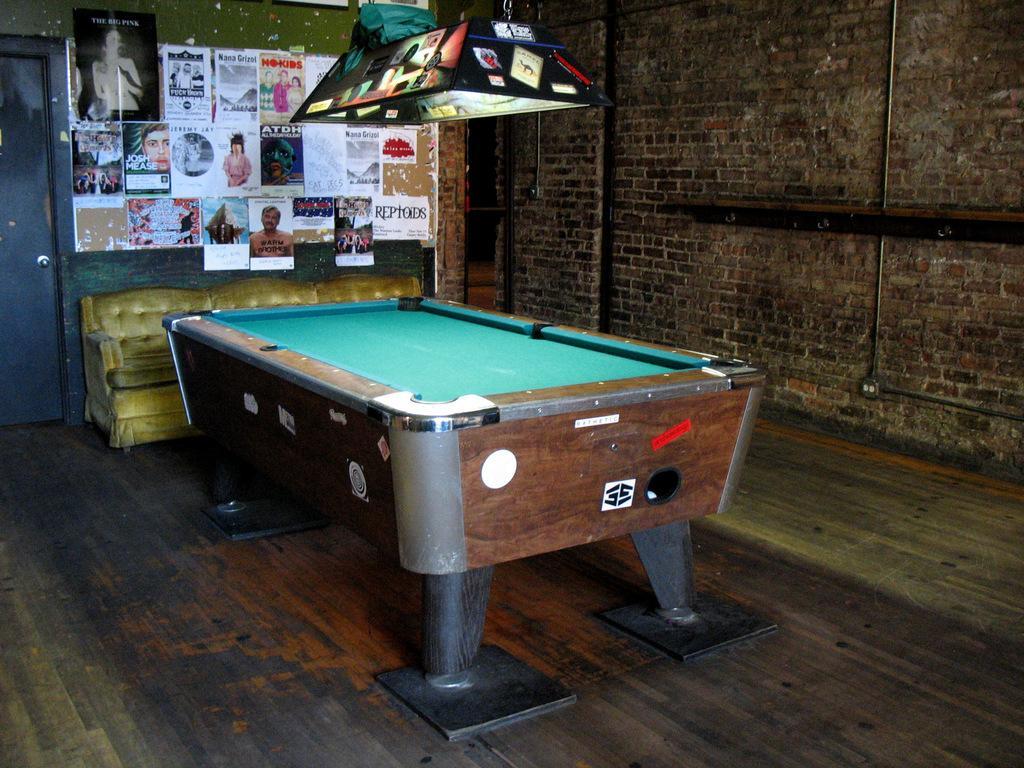Can you describe this image briefly? In this image I can see a snooker and a table. On this wall I can few stickers and posters. I can also see a door. 